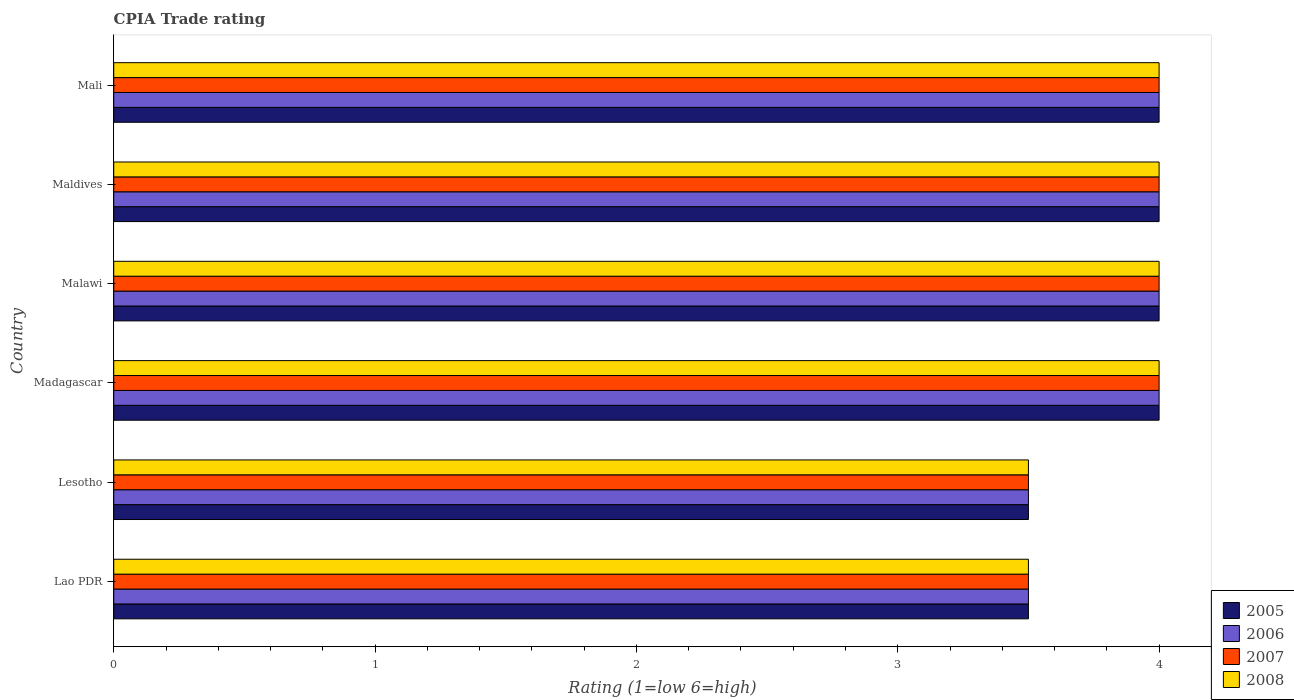How many different coloured bars are there?
Your answer should be compact. 4. What is the label of the 1st group of bars from the top?
Provide a succinct answer. Mali. What is the CPIA rating in 2007 in Lesotho?
Ensure brevity in your answer.  3.5. Across all countries, what is the maximum CPIA rating in 2006?
Ensure brevity in your answer.  4. In which country was the CPIA rating in 2007 maximum?
Your answer should be compact. Madagascar. In which country was the CPIA rating in 2006 minimum?
Make the answer very short. Lao PDR. What is the total CPIA rating in 2006 in the graph?
Offer a terse response. 23. What is the difference between the CPIA rating in 2008 in Madagascar and that in Maldives?
Make the answer very short. 0. What is the difference between the CPIA rating in 2007 in Mali and the CPIA rating in 2006 in Madagascar?
Your answer should be very brief. 0. What is the average CPIA rating in 2006 per country?
Offer a terse response. 3.83. What is the difference between the CPIA rating in 2008 and CPIA rating in 2006 in Lao PDR?
Give a very brief answer. 0. In how many countries, is the CPIA rating in 2006 greater than 2.2 ?
Provide a succinct answer. 6. What is the ratio of the CPIA rating in 2005 in Malawi to that in Maldives?
Your response must be concise. 1. Is the CPIA rating in 2005 in Lao PDR less than that in Madagascar?
Your response must be concise. Yes. What is the difference between the highest and the second highest CPIA rating in 2005?
Keep it short and to the point. 0. What is the difference between the highest and the lowest CPIA rating in 2008?
Offer a terse response. 0.5. In how many countries, is the CPIA rating in 2008 greater than the average CPIA rating in 2008 taken over all countries?
Offer a very short reply. 4. Is it the case that in every country, the sum of the CPIA rating in 2005 and CPIA rating in 2007 is greater than the sum of CPIA rating in 2008 and CPIA rating in 2006?
Make the answer very short. No. What does the 1st bar from the top in Lao PDR represents?
Make the answer very short. 2008. How many bars are there?
Provide a succinct answer. 24. What is the difference between two consecutive major ticks on the X-axis?
Provide a short and direct response. 1. Are the values on the major ticks of X-axis written in scientific E-notation?
Your answer should be compact. No. How are the legend labels stacked?
Your answer should be compact. Vertical. What is the title of the graph?
Ensure brevity in your answer.  CPIA Trade rating. What is the label or title of the X-axis?
Provide a succinct answer. Rating (1=low 6=high). What is the Rating (1=low 6=high) of 2006 in Lao PDR?
Your answer should be compact. 3.5. What is the Rating (1=low 6=high) of 2007 in Lao PDR?
Your answer should be compact. 3.5. What is the Rating (1=low 6=high) in 2008 in Lao PDR?
Provide a succinct answer. 3.5. What is the Rating (1=low 6=high) of 2006 in Lesotho?
Your answer should be compact. 3.5. What is the Rating (1=low 6=high) of 2005 in Madagascar?
Ensure brevity in your answer.  4. What is the Rating (1=low 6=high) in 2008 in Madagascar?
Your response must be concise. 4. What is the Rating (1=low 6=high) of 2005 in Malawi?
Your response must be concise. 4. What is the Rating (1=low 6=high) in 2007 in Malawi?
Your response must be concise. 4. What is the Rating (1=low 6=high) of 2008 in Malawi?
Provide a succinct answer. 4. What is the Rating (1=low 6=high) in 2006 in Maldives?
Your answer should be compact. 4. What is the Rating (1=low 6=high) of 2008 in Maldives?
Your answer should be compact. 4. What is the Rating (1=low 6=high) in 2005 in Mali?
Offer a terse response. 4. What is the Rating (1=low 6=high) of 2008 in Mali?
Offer a very short reply. 4. Across all countries, what is the maximum Rating (1=low 6=high) in 2008?
Make the answer very short. 4. Across all countries, what is the minimum Rating (1=low 6=high) of 2005?
Offer a very short reply. 3.5. Across all countries, what is the minimum Rating (1=low 6=high) in 2006?
Provide a succinct answer. 3.5. Across all countries, what is the minimum Rating (1=low 6=high) in 2008?
Offer a very short reply. 3.5. What is the total Rating (1=low 6=high) in 2005 in the graph?
Your response must be concise. 23. What is the total Rating (1=low 6=high) in 2008 in the graph?
Provide a short and direct response. 23. What is the difference between the Rating (1=low 6=high) of 2006 in Lao PDR and that in Lesotho?
Offer a terse response. 0. What is the difference between the Rating (1=low 6=high) of 2008 in Lao PDR and that in Lesotho?
Ensure brevity in your answer.  0. What is the difference between the Rating (1=low 6=high) of 2005 in Lao PDR and that in Madagascar?
Keep it short and to the point. -0.5. What is the difference between the Rating (1=low 6=high) of 2007 in Lao PDR and that in Madagascar?
Give a very brief answer. -0.5. What is the difference between the Rating (1=low 6=high) in 2008 in Lao PDR and that in Madagascar?
Ensure brevity in your answer.  -0.5. What is the difference between the Rating (1=low 6=high) of 2008 in Lao PDR and that in Malawi?
Offer a terse response. -0.5. What is the difference between the Rating (1=low 6=high) in 2005 in Lao PDR and that in Maldives?
Offer a very short reply. -0.5. What is the difference between the Rating (1=low 6=high) in 2006 in Lao PDR and that in Maldives?
Your answer should be compact. -0.5. What is the difference between the Rating (1=low 6=high) of 2007 in Lao PDR and that in Maldives?
Offer a very short reply. -0.5. What is the difference between the Rating (1=low 6=high) in 2005 in Lao PDR and that in Mali?
Ensure brevity in your answer.  -0.5. What is the difference between the Rating (1=low 6=high) in 2006 in Lao PDR and that in Mali?
Provide a succinct answer. -0.5. What is the difference between the Rating (1=low 6=high) in 2008 in Lao PDR and that in Mali?
Your answer should be very brief. -0.5. What is the difference between the Rating (1=low 6=high) in 2006 in Lesotho and that in Madagascar?
Make the answer very short. -0.5. What is the difference between the Rating (1=low 6=high) in 2008 in Lesotho and that in Madagascar?
Offer a very short reply. -0.5. What is the difference between the Rating (1=low 6=high) in 2006 in Lesotho and that in Malawi?
Your response must be concise. -0.5. What is the difference between the Rating (1=low 6=high) of 2008 in Lesotho and that in Malawi?
Make the answer very short. -0.5. What is the difference between the Rating (1=low 6=high) of 2007 in Lesotho and that in Maldives?
Offer a terse response. -0.5. What is the difference between the Rating (1=low 6=high) of 2008 in Lesotho and that in Mali?
Offer a very short reply. -0.5. What is the difference between the Rating (1=low 6=high) in 2007 in Madagascar and that in Malawi?
Your response must be concise. 0. What is the difference between the Rating (1=low 6=high) of 2008 in Madagascar and that in Malawi?
Make the answer very short. 0. What is the difference between the Rating (1=low 6=high) in 2007 in Madagascar and that in Maldives?
Make the answer very short. 0. What is the difference between the Rating (1=low 6=high) of 2006 in Madagascar and that in Mali?
Give a very brief answer. 0. What is the difference between the Rating (1=low 6=high) of 2008 in Malawi and that in Maldives?
Offer a terse response. 0. What is the difference between the Rating (1=low 6=high) in 2006 in Malawi and that in Mali?
Give a very brief answer. 0. What is the difference between the Rating (1=low 6=high) in 2008 in Malawi and that in Mali?
Your response must be concise. 0. What is the difference between the Rating (1=low 6=high) of 2005 in Maldives and that in Mali?
Offer a terse response. 0. What is the difference between the Rating (1=low 6=high) of 2007 in Maldives and that in Mali?
Your response must be concise. 0. What is the difference between the Rating (1=low 6=high) of 2008 in Maldives and that in Mali?
Offer a very short reply. 0. What is the difference between the Rating (1=low 6=high) in 2005 in Lao PDR and the Rating (1=low 6=high) in 2006 in Lesotho?
Offer a very short reply. 0. What is the difference between the Rating (1=low 6=high) of 2005 in Lao PDR and the Rating (1=low 6=high) of 2007 in Lesotho?
Ensure brevity in your answer.  0. What is the difference between the Rating (1=low 6=high) of 2006 in Lao PDR and the Rating (1=low 6=high) of 2007 in Lesotho?
Offer a terse response. 0. What is the difference between the Rating (1=low 6=high) in 2005 in Lao PDR and the Rating (1=low 6=high) in 2006 in Madagascar?
Your answer should be compact. -0.5. What is the difference between the Rating (1=low 6=high) of 2005 in Lao PDR and the Rating (1=low 6=high) of 2007 in Madagascar?
Ensure brevity in your answer.  -0.5. What is the difference between the Rating (1=low 6=high) of 2005 in Lao PDR and the Rating (1=low 6=high) of 2008 in Madagascar?
Offer a very short reply. -0.5. What is the difference between the Rating (1=low 6=high) of 2005 in Lao PDR and the Rating (1=low 6=high) of 2007 in Malawi?
Give a very brief answer. -0.5. What is the difference between the Rating (1=low 6=high) in 2005 in Lao PDR and the Rating (1=low 6=high) in 2008 in Malawi?
Your answer should be compact. -0.5. What is the difference between the Rating (1=low 6=high) in 2006 in Lao PDR and the Rating (1=low 6=high) in 2007 in Malawi?
Provide a succinct answer. -0.5. What is the difference between the Rating (1=low 6=high) in 2005 in Lao PDR and the Rating (1=low 6=high) in 2006 in Maldives?
Give a very brief answer. -0.5. What is the difference between the Rating (1=low 6=high) in 2005 in Lao PDR and the Rating (1=low 6=high) in 2006 in Mali?
Your answer should be compact. -0.5. What is the difference between the Rating (1=low 6=high) in 2005 in Lao PDR and the Rating (1=low 6=high) in 2008 in Mali?
Your response must be concise. -0.5. What is the difference between the Rating (1=low 6=high) of 2006 in Lao PDR and the Rating (1=low 6=high) of 2007 in Mali?
Ensure brevity in your answer.  -0.5. What is the difference between the Rating (1=low 6=high) of 2006 in Lao PDR and the Rating (1=low 6=high) of 2008 in Mali?
Offer a very short reply. -0.5. What is the difference between the Rating (1=low 6=high) of 2007 in Lao PDR and the Rating (1=low 6=high) of 2008 in Mali?
Offer a very short reply. -0.5. What is the difference between the Rating (1=low 6=high) of 2005 in Lesotho and the Rating (1=low 6=high) of 2006 in Madagascar?
Offer a very short reply. -0.5. What is the difference between the Rating (1=low 6=high) of 2005 in Lesotho and the Rating (1=low 6=high) of 2008 in Madagascar?
Make the answer very short. -0.5. What is the difference between the Rating (1=low 6=high) in 2006 in Lesotho and the Rating (1=low 6=high) in 2008 in Madagascar?
Your answer should be compact. -0.5. What is the difference between the Rating (1=low 6=high) of 2007 in Lesotho and the Rating (1=low 6=high) of 2008 in Madagascar?
Your answer should be compact. -0.5. What is the difference between the Rating (1=low 6=high) of 2005 in Lesotho and the Rating (1=low 6=high) of 2007 in Malawi?
Offer a very short reply. -0.5. What is the difference between the Rating (1=low 6=high) of 2006 in Lesotho and the Rating (1=low 6=high) of 2007 in Malawi?
Make the answer very short. -0.5. What is the difference between the Rating (1=low 6=high) in 2007 in Lesotho and the Rating (1=low 6=high) in 2008 in Malawi?
Your answer should be very brief. -0.5. What is the difference between the Rating (1=low 6=high) of 2005 in Lesotho and the Rating (1=low 6=high) of 2006 in Maldives?
Provide a succinct answer. -0.5. What is the difference between the Rating (1=low 6=high) in 2006 in Lesotho and the Rating (1=low 6=high) in 2007 in Maldives?
Make the answer very short. -0.5. What is the difference between the Rating (1=low 6=high) in 2005 in Lesotho and the Rating (1=low 6=high) in 2006 in Mali?
Ensure brevity in your answer.  -0.5. What is the difference between the Rating (1=low 6=high) of 2006 in Lesotho and the Rating (1=low 6=high) of 2008 in Mali?
Your response must be concise. -0.5. What is the difference between the Rating (1=low 6=high) in 2007 in Lesotho and the Rating (1=low 6=high) in 2008 in Mali?
Make the answer very short. -0.5. What is the difference between the Rating (1=low 6=high) in 2005 in Madagascar and the Rating (1=low 6=high) in 2006 in Malawi?
Your answer should be very brief. 0. What is the difference between the Rating (1=low 6=high) in 2005 in Madagascar and the Rating (1=low 6=high) in 2008 in Malawi?
Make the answer very short. 0. What is the difference between the Rating (1=low 6=high) of 2006 in Madagascar and the Rating (1=low 6=high) of 2008 in Malawi?
Ensure brevity in your answer.  0. What is the difference between the Rating (1=low 6=high) of 2007 in Madagascar and the Rating (1=low 6=high) of 2008 in Malawi?
Offer a very short reply. 0. What is the difference between the Rating (1=low 6=high) in 2005 in Madagascar and the Rating (1=low 6=high) in 2006 in Maldives?
Your answer should be very brief. 0. What is the difference between the Rating (1=low 6=high) in 2005 in Madagascar and the Rating (1=low 6=high) in 2008 in Maldives?
Make the answer very short. 0. What is the difference between the Rating (1=low 6=high) in 2006 in Madagascar and the Rating (1=low 6=high) in 2008 in Maldives?
Provide a short and direct response. 0. What is the difference between the Rating (1=low 6=high) in 2005 in Madagascar and the Rating (1=low 6=high) in 2006 in Mali?
Offer a terse response. 0. What is the difference between the Rating (1=low 6=high) in 2005 in Madagascar and the Rating (1=low 6=high) in 2008 in Mali?
Your answer should be very brief. 0. What is the difference between the Rating (1=low 6=high) in 2006 in Madagascar and the Rating (1=low 6=high) in 2007 in Mali?
Your answer should be very brief. 0. What is the difference between the Rating (1=low 6=high) of 2006 in Madagascar and the Rating (1=low 6=high) of 2008 in Mali?
Your answer should be compact. 0. What is the difference between the Rating (1=low 6=high) of 2007 in Madagascar and the Rating (1=low 6=high) of 2008 in Mali?
Your response must be concise. 0. What is the difference between the Rating (1=low 6=high) in 2005 in Malawi and the Rating (1=low 6=high) in 2006 in Maldives?
Offer a very short reply. 0. What is the difference between the Rating (1=low 6=high) in 2005 in Malawi and the Rating (1=low 6=high) in 2008 in Maldives?
Offer a very short reply. 0. What is the difference between the Rating (1=low 6=high) of 2005 in Malawi and the Rating (1=low 6=high) of 2007 in Mali?
Ensure brevity in your answer.  0. What is the difference between the Rating (1=low 6=high) in 2006 in Malawi and the Rating (1=low 6=high) in 2007 in Mali?
Keep it short and to the point. 0. What is the difference between the Rating (1=low 6=high) of 2006 in Malawi and the Rating (1=low 6=high) of 2008 in Mali?
Provide a short and direct response. 0. What is the difference between the Rating (1=low 6=high) in 2005 in Maldives and the Rating (1=low 6=high) in 2006 in Mali?
Your response must be concise. 0. What is the difference between the Rating (1=low 6=high) of 2005 in Maldives and the Rating (1=low 6=high) of 2007 in Mali?
Provide a succinct answer. 0. What is the difference between the Rating (1=low 6=high) of 2005 in Maldives and the Rating (1=low 6=high) of 2008 in Mali?
Your answer should be compact. 0. What is the difference between the Rating (1=low 6=high) in 2006 in Maldives and the Rating (1=low 6=high) in 2007 in Mali?
Offer a terse response. 0. What is the difference between the Rating (1=low 6=high) in 2006 in Maldives and the Rating (1=low 6=high) in 2008 in Mali?
Offer a very short reply. 0. What is the average Rating (1=low 6=high) in 2005 per country?
Your answer should be compact. 3.83. What is the average Rating (1=low 6=high) in 2006 per country?
Provide a short and direct response. 3.83. What is the average Rating (1=low 6=high) of 2007 per country?
Make the answer very short. 3.83. What is the average Rating (1=low 6=high) of 2008 per country?
Provide a succinct answer. 3.83. What is the difference between the Rating (1=low 6=high) of 2005 and Rating (1=low 6=high) of 2007 in Lao PDR?
Provide a short and direct response. 0. What is the difference between the Rating (1=low 6=high) of 2006 and Rating (1=low 6=high) of 2008 in Lao PDR?
Ensure brevity in your answer.  0. What is the difference between the Rating (1=low 6=high) in 2007 and Rating (1=low 6=high) in 2008 in Lao PDR?
Ensure brevity in your answer.  0. What is the difference between the Rating (1=low 6=high) of 2006 and Rating (1=low 6=high) of 2007 in Lesotho?
Your response must be concise. 0. What is the difference between the Rating (1=low 6=high) in 2005 and Rating (1=low 6=high) in 2006 in Madagascar?
Ensure brevity in your answer.  0. What is the difference between the Rating (1=low 6=high) of 2006 and Rating (1=low 6=high) of 2007 in Madagascar?
Keep it short and to the point. 0. What is the difference between the Rating (1=low 6=high) of 2005 and Rating (1=low 6=high) of 2007 in Malawi?
Provide a succinct answer. 0. What is the difference between the Rating (1=low 6=high) of 2006 and Rating (1=low 6=high) of 2007 in Malawi?
Make the answer very short. 0. What is the difference between the Rating (1=low 6=high) of 2006 and Rating (1=low 6=high) of 2008 in Malawi?
Give a very brief answer. 0. What is the difference between the Rating (1=low 6=high) of 2007 and Rating (1=low 6=high) of 2008 in Malawi?
Your response must be concise. 0. What is the difference between the Rating (1=low 6=high) of 2005 and Rating (1=low 6=high) of 2006 in Maldives?
Provide a short and direct response. 0. What is the difference between the Rating (1=low 6=high) of 2005 and Rating (1=low 6=high) of 2008 in Maldives?
Give a very brief answer. 0. What is the difference between the Rating (1=low 6=high) in 2006 and Rating (1=low 6=high) in 2007 in Maldives?
Keep it short and to the point. 0. What is the difference between the Rating (1=low 6=high) in 2005 and Rating (1=low 6=high) in 2007 in Mali?
Your response must be concise. 0. What is the difference between the Rating (1=low 6=high) in 2005 and Rating (1=low 6=high) in 2008 in Mali?
Provide a short and direct response. 0. What is the difference between the Rating (1=low 6=high) in 2007 and Rating (1=low 6=high) in 2008 in Mali?
Offer a terse response. 0. What is the ratio of the Rating (1=low 6=high) of 2006 in Lao PDR to that in Lesotho?
Offer a very short reply. 1. What is the ratio of the Rating (1=low 6=high) of 2008 in Lao PDR to that in Lesotho?
Offer a terse response. 1. What is the ratio of the Rating (1=low 6=high) in 2007 in Lao PDR to that in Madagascar?
Your response must be concise. 0.88. What is the ratio of the Rating (1=low 6=high) of 2008 in Lao PDR to that in Malawi?
Offer a terse response. 0.88. What is the ratio of the Rating (1=low 6=high) of 2005 in Lao PDR to that in Mali?
Provide a succinct answer. 0.88. What is the ratio of the Rating (1=low 6=high) in 2006 in Lao PDR to that in Mali?
Your answer should be very brief. 0.88. What is the ratio of the Rating (1=low 6=high) of 2007 in Lao PDR to that in Mali?
Your answer should be compact. 0.88. What is the ratio of the Rating (1=low 6=high) in 2005 in Lesotho to that in Madagascar?
Your response must be concise. 0.88. What is the ratio of the Rating (1=low 6=high) of 2005 in Lesotho to that in Malawi?
Offer a terse response. 0.88. What is the ratio of the Rating (1=low 6=high) of 2007 in Lesotho to that in Malawi?
Keep it short and to the point. 0.88. What is the ratio of the Rating (1=low 6=high) in 2005 in Lesotho to that in Maldives?
Offer a terse response. 0.88. What is the ratio of the Rating (1=low 6=high) in 2008 in Lesotho to that in Maldives?
Offer a very short reply. 0.88. What is the ratio of the Rating (1=low 6=high) of 2007 in Lesotho to that in Mali?
Make the answer very short. 0.88. What is the ratio of the Rating (1=low 6=high) in 2008 in Lesotho to that in Mali?
Ensure brevity in your answer.  0.88. What is the ratio of the Rating (1=low 6=high) in 2008 in Madagascar to that in Malawi?
Offer a terse response. 1. What is the ratio of the Rating (1=low 6=high) of 2005 in Madagascar to that in Maldives?
Keep it short and to the point. 1. What is the ratio of the Rating (1=low 6=high) of 2006 in Madagascar to that in Maldives?
Give a very brief answer. 1. What is the ratio of the Rating (1=low 6=high) in 2008 in Madagascar to that in Maldives?
Offer a terse response. 1. What is the ratio of the Rating (1=low 6=high) of 2005 in Madagascar to that in Mali?
Your response must be concise. 1. What is the ratio of the Rating (1=low 6=high) of 2006 in Madagascar to that in Mali?
Keep it short and to the point. 1. What is the ratio of the Rating (1=low 6=high) of 2007 in Madagascar to that in Mali?
Your response must be concise. 1. What is the ratio of the Rating (1=low 6=high) in 2005 in Malawi to that in Maldives?
Your answer should be compact. 1. What is the ratio of the Rating (1=low 6=high) in 2006 in Malawi to that in Mali?
Offer a very short reply. 1. What is the ratio of the Rating (1=low 6=high) of 2007 in Malawi to that in Mali?
Your answer should be very brief. 1. What is the ratio of the Rating (1=low 6=high) in 2008 in Malawi to that in Mali?
Provide a short and direct response. 1. What is the ratio of the Rating (1=low 6=high) in 2008 in Maldives to that in Mali?
Keep it short and to the point. 1. What is the difference between the highest and the second highest Rating (1=low 6=high) in 2005?
Make the answer very short. 0. What is the difference between the highest and the second highest Rating (1=low 6=high) of 2007?
Provide a short and direct response. 0. What is the difference between the highest and the second highest Rating (1=low 6=high) of 2008?
Your answer should be very brief. 0. What is the difference between the highest and the lowest Rating (1=low 6=high) in 2006?
Provide a succinct answer. 0.5. What is the difference between the highest and the lowest Rating (1=low 6=high) of 2007?
Offer a very short reply. 0.5. 